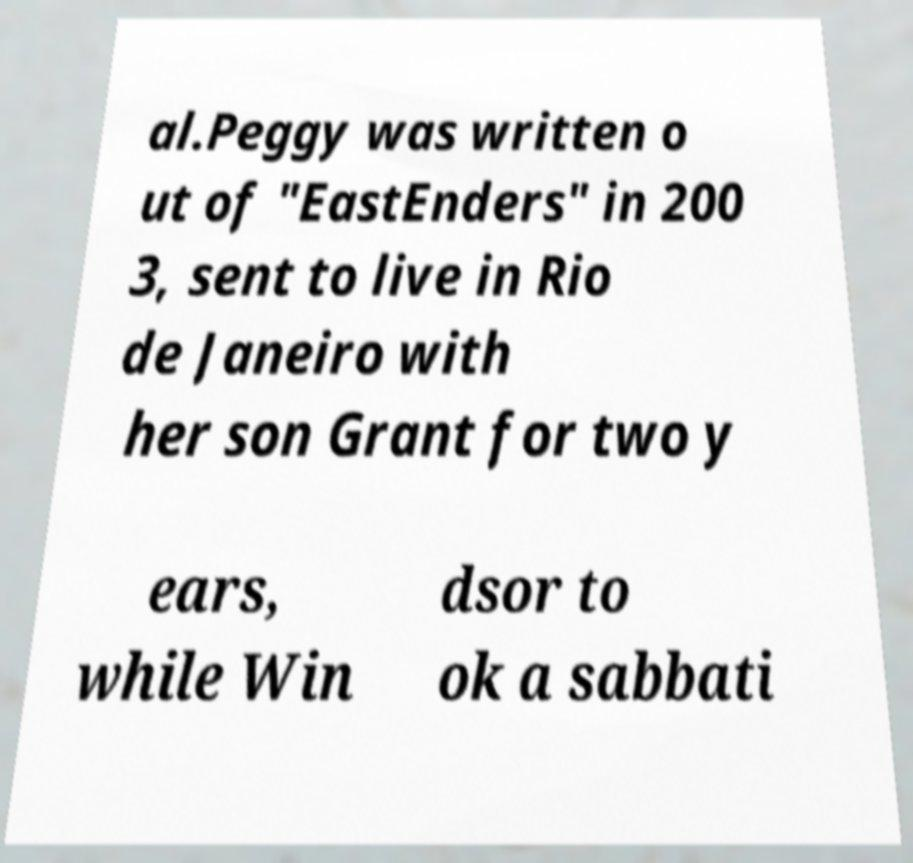For documentation purposes, I need the text within this image transcribed. Could you provide that? al.Peggy was written o ut of "EastEnders" in 200 3, sent to live in Rio de Janeiro with her son Grant for two y ears, while Win dsor to ok a sabbati 